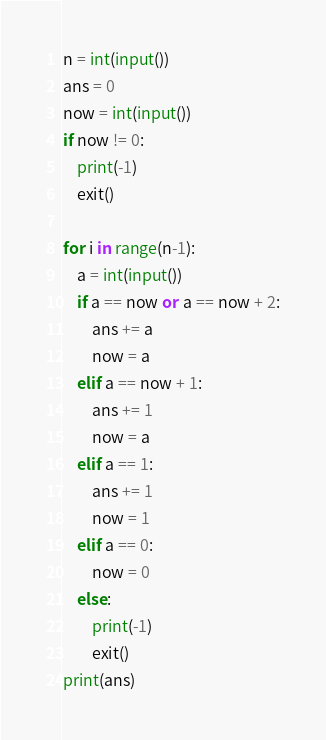<code> <loc_0><loc_0><loc_500><loc_500><_Python_>n = int(input())
ans = 0
now = int(input())
if now != 0:
    print(-1)
    exit()

for i in range(n-1):
    a = int(input())
    if a == now or a == now + 2:
        ans += a
        now = a
    elif a == now + 1:
        ans += 1
        now = a
    elif a == 1:
        ans += 1
        now = 1
    elif a == 0:
        now = 0
    else:
        print(-1)
        exit()
print(ans)</code> 